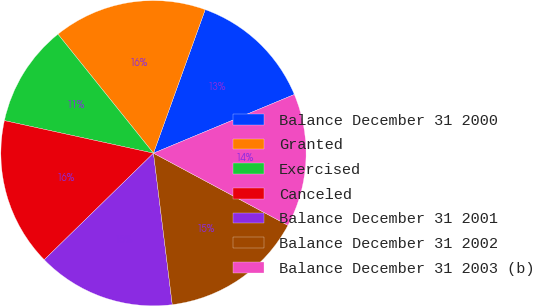<chart> <loc_0><loc_0><loc_500><loc_500><pie_chart><fcel>Balance December 31 2000<fcel>Granted<fcel>Exercised<fcel>Canceled<fcel>Balance December 31 2001<fcel>Balance December 31 2002<fcel>Balance December 31 2003 (b)<nl><fcel>13.21%<fcel>16.27%<fcel>10.81%<fcel>15.73%<fcel>14.66%<fcel>15.2%<fcel>14.12%<nl></chart> 